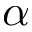<formula> <loc_0><loc_0><loc_500><loc_500>\alpha</formula> 